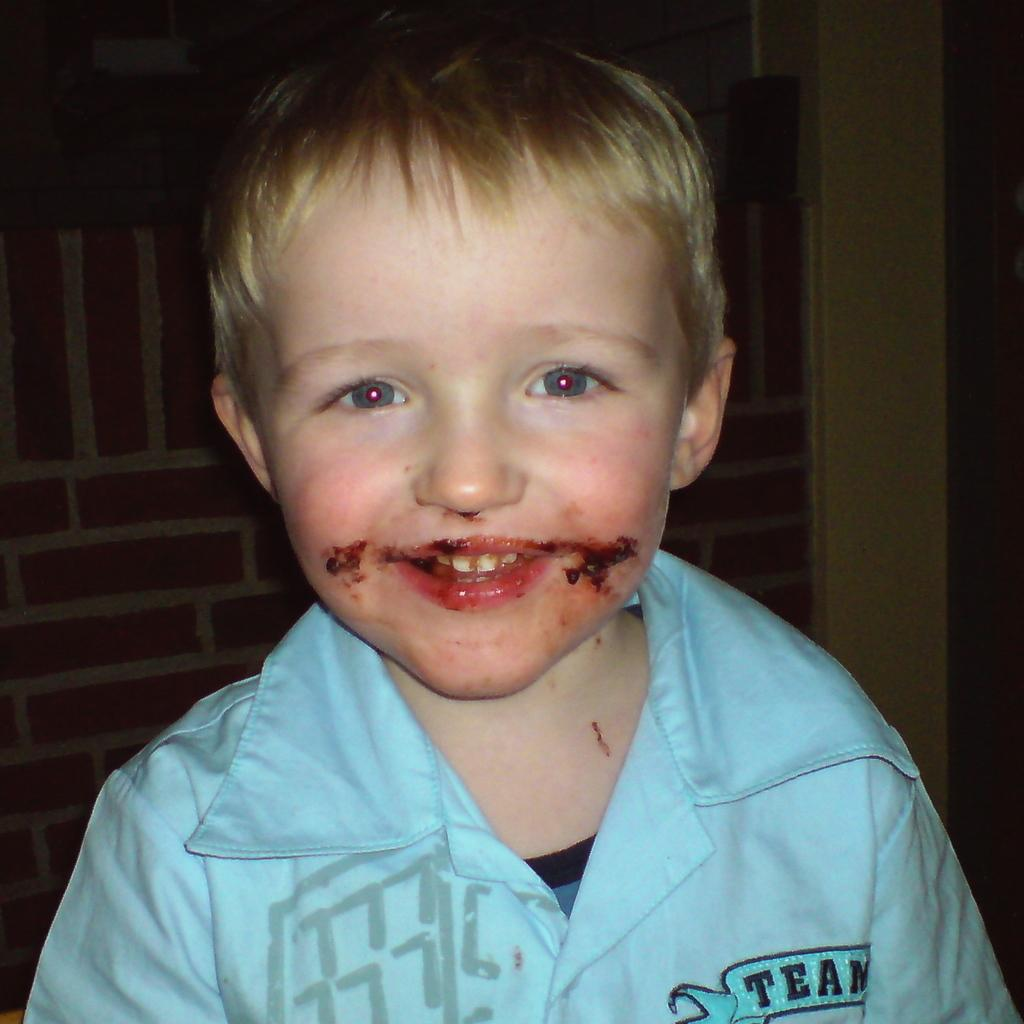What is the main subject of the image? There is a boy in the image. What is the boy wearing? The boy is wearing a blue shirt. What can be seen in the background of the image? There is a metal grill and a wall in the background of the image. Can you see the ocean in the background of the image? No, the ocean is not present in the image. What type of property is the boy standing on in the image? The image does not provide information about the type of property or surface the boy is standing on. 